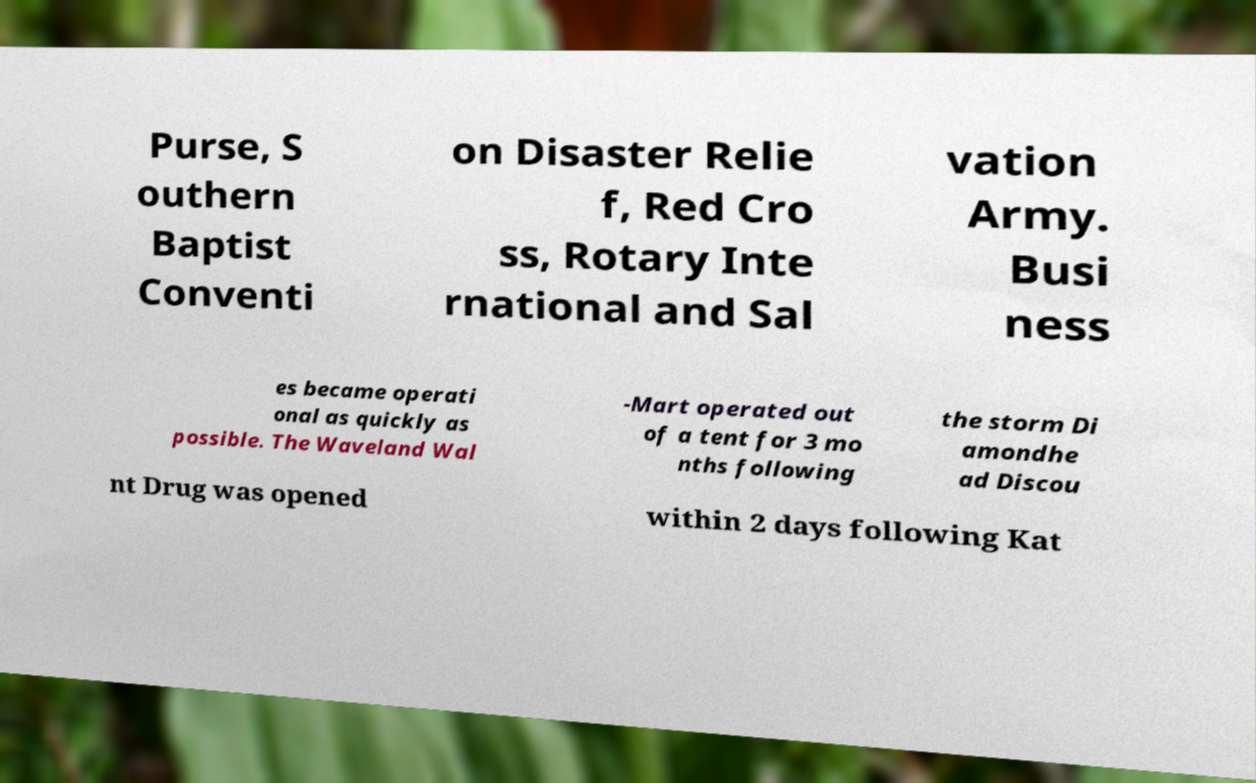Could you extract and type out the text from this image? Purse, S outhern Baptist Conventi on Disaster Relie f, Red Cro ss, Rotary Inte rnational and Sal vation Army. Busi ness es became operati onal as quickly as possible. The Waveland Wal -Mart operated out of a tent for 3 mo nths following the storm Di amondhe ad Discou nt Drug was opened within 2 days following Kat 